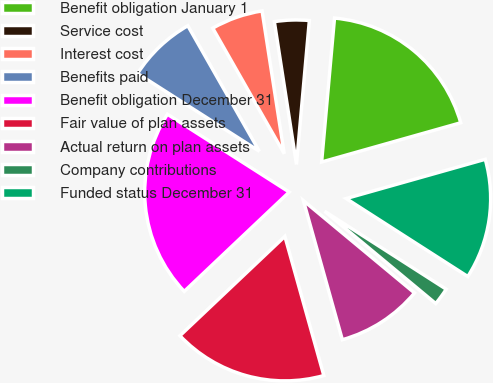Convert chart to OTSL. <chart><loc_0><loc_0><loc_500><loc_500><pie_chart><fcel>Benefit obligation January 1<fcel>Service cost<fcel>Interest cost<fcel>Benefits paid<fcel>Benefit obligation December 31<fcel>Fair value of plan assets<fcel>Actual return on plan assets<fcel>Company contributions<fcel>Funded status December 31<nl><fcel>19.2%<fcel>3.87%<fcel>5.79%<fcel>7.71%<fcel>21.11%<fcel>17.28%<fcel>9.62%<fcel>1.96%<fcel>13.45%<nl></chart> 